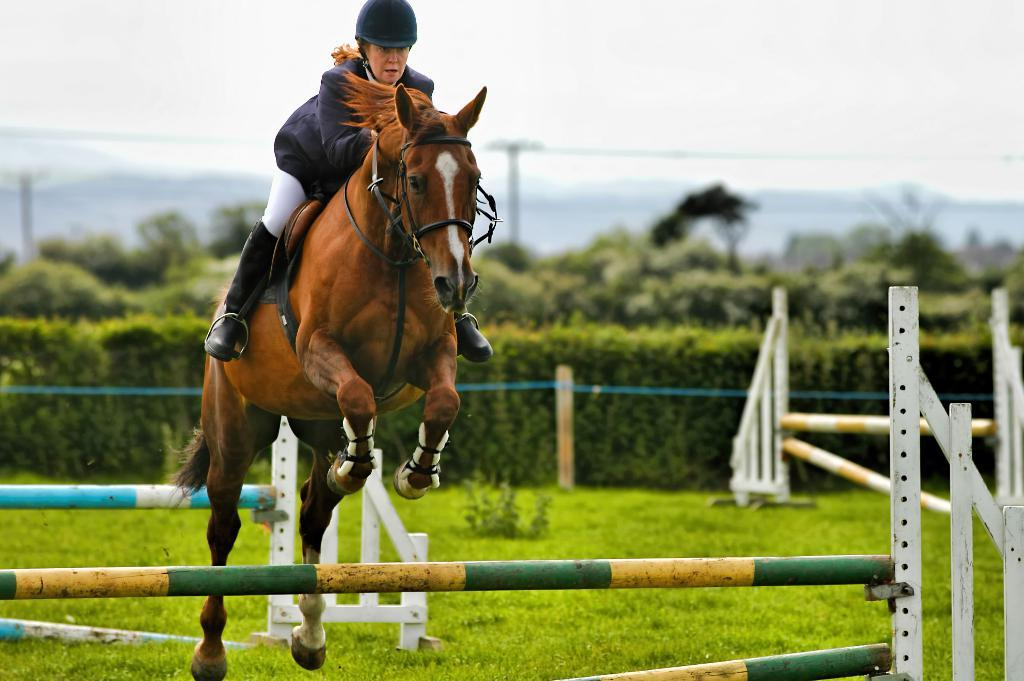Who is the main subject in the image? There is a woman in the image. What is the woman doing in the image? The woman is riding a horse. What type of vegetation can be seen in the image? There are plants visible in the image. What is visible in the background of the image? The sky is visible in the image. What type of care can be seen being provided to the geese in the image? There are no geese present in the image, so no care can be observed. Is there any snow visible in the image? There is no snow visible in the image; the sky is visible, but no snow is mentioned in the facts. 